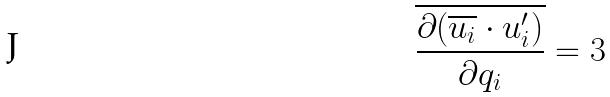<formula> <loc_0><loc_0><loc_500><loc_500>\overline { \frac { \partial ( \overline { u _ { i } } \cdot u _ { i } ^ { \prime } ) } { \partial q _ { i } } } = 3</formula> 